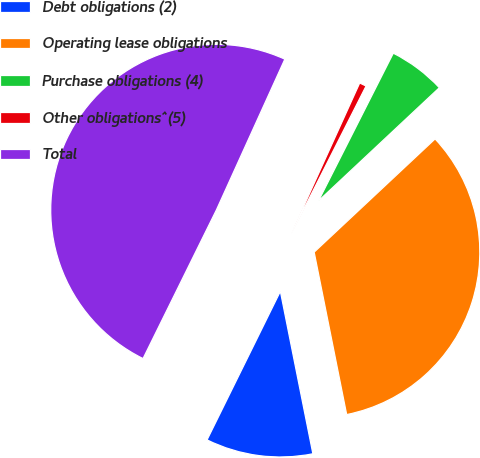<chart> <loc_0><loc_0><loc_500><loc_500><pie_chart><fcel>Debt obligations (2)<fcel>Operating lease obligations<fcel>Purchase obligations (4)<fcel>Other obligations^(5)<fcel>Total<nl><fcel>10.44%<fcel>33.83%<fcel>5.56%<fcel>0.68%<fcel>49.48%<nl></chart> 